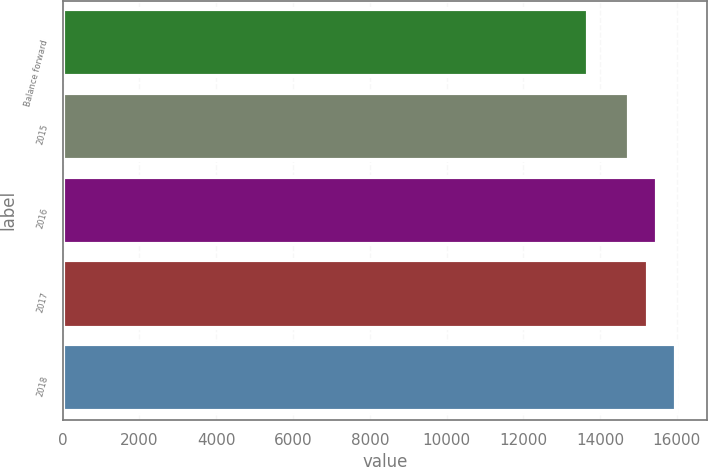<chart> <loc_0><loc_0><loc_500><loc_500><bar_chart><fcel>Balance forward<fcel>2015<fcel>2016<fcel>2017<fcel>2018<nl><fcel>13697<fcel>14762<fcel>15489.3<fcel>15260<fcel>15990<nl></chart> 